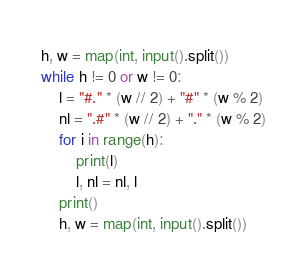Convert code to text. <code><loc_0><loc_0><loc_500><loc_500><_Python_>h, w = map(int, input().split())
while h != 0 or w != 0:
    l = "#." * (w // 2) + "#" * (w % 2)
    nl = ".#" * (w // 2) + "." * (w % 2)
    for i in range(h):
        print(l)
        l, nl = nl, l
    print()
    h, w = map(int, input().split())

</code> 